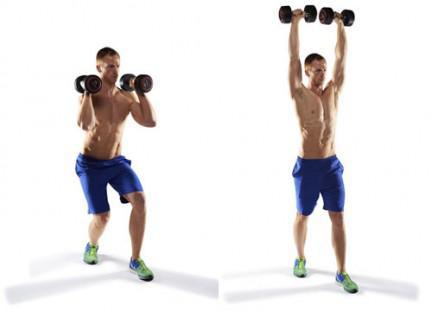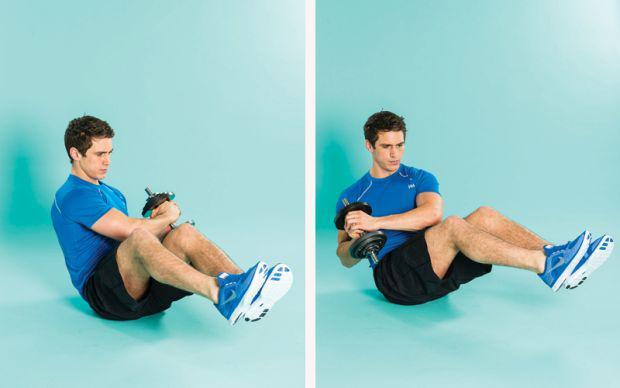The first image is the image on the left, the second image is the image on the right. Evaluate the accuracy of this statement regarding the images: "An image shows a workout sequence featuring a man in blue shorts with dumbbells in each hand.". Is it true? Answer yes or no. Yes. 